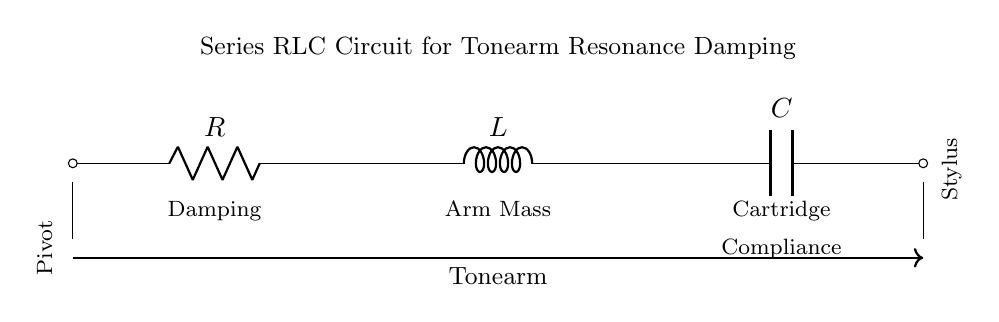What are the components in this circuit? The circuit consists of a resistor, an inductor, and a capacitor, which can be identified by their labels. Each component also has a distinct symbol in the diagram.
Answer: Resistor, inductor, capacitor Where is the tonearm located in this circuit? The tonearm is indicated by the label positioned below the connection line of the circuit, reflecting its placement in the turntable.
Answer: Below the circuit What does the 'R' represent in this circuit? The 'R' stands for the resistor, and it denotes the component responsible for resistance in the circuit.
Answer: Resistor How does damping relate to the circuit components? Damping is the process that reduces oscillations in the circuit, and in this case, it's correlated with the presence of the resistor, inductor, and capacitor working together to manage the resonant frequency.
Answer: Damping What is the role of the inductor in this circuit? The inductor stores energy in a magnetic field when current passes through it, contributing to the resonance characteristics important for turntable performance.
Answer: Energy storage What is the significance of compliance in the circuit? Compliance refers to the flexibility of the cartridge, which impacts how effectively the stylus tracks the grooves of a record, thus affecting the overall sound quality.
Answer: Flexibility 